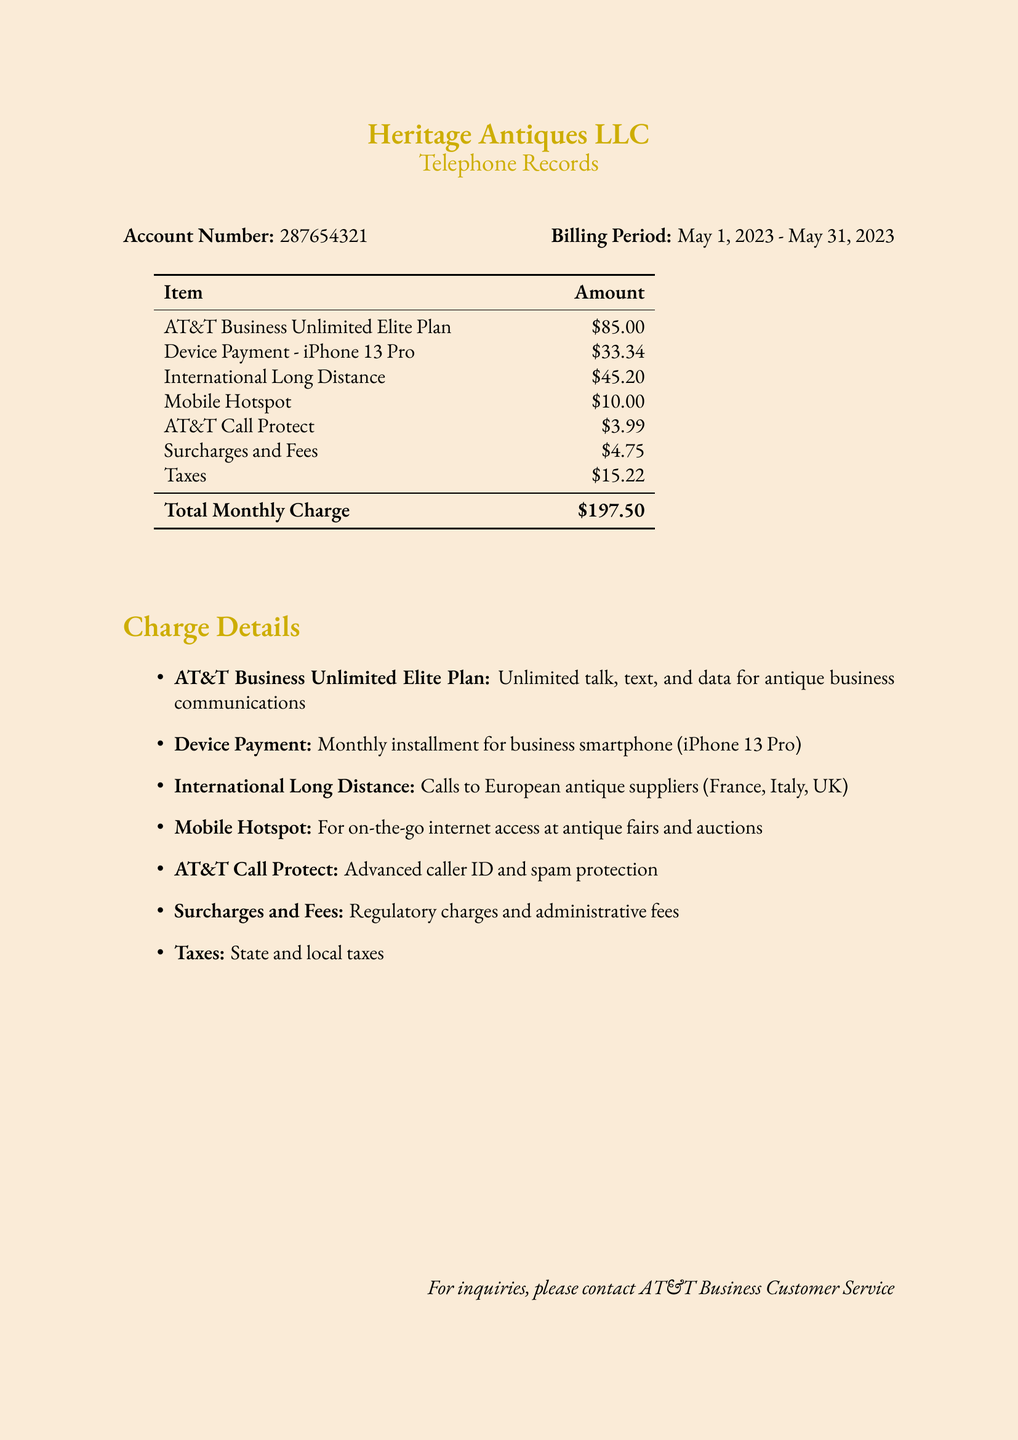What is the account number? The account number is listed prominently in the document as a key identification number.
Answer: 287654321 What is the billing period? The billing period indicates the range of dates for which charges are calculated and is specifically stated in the document.
Answer: May 1, 2023 - May 31, 2023 What is the total monthly charge? The total monthly charge is calculated by summing all individual charges outlined in the table.
Answer: $197.50 How much is the charge for International Long Distance? The charge for International Long Distance is specifically listed in the itemized charges.
Answer: $45.20 What type of phone plan is mentioned? The document provides details about the specific plan used for business communications.
Answer: AT&T Business Unlimited Elite Plan What is the purpose of the Mobile Hotspot charge? The Mobile Hotspot charge is described in the context of its use for antique fairs and auctions, highlighting its importance for business operations.
Answer: On-the-go internet access What is included in the AT&T Business Unlimited Elite Plan? The document outlines what the plan offers in terms of communication capabilities for the antique business.
Answer: Unlimited talk, text, and data What is the device mentioned in the document? A specific smartphone is referenced in the context of a monthly payment as part of the charges.
Answer: iPhone 13 Pro How much are the surcharges and fees? Surcharges and fees are categorized as a distinct line item within the document, providing a clear amount.
Answer: $4.75 